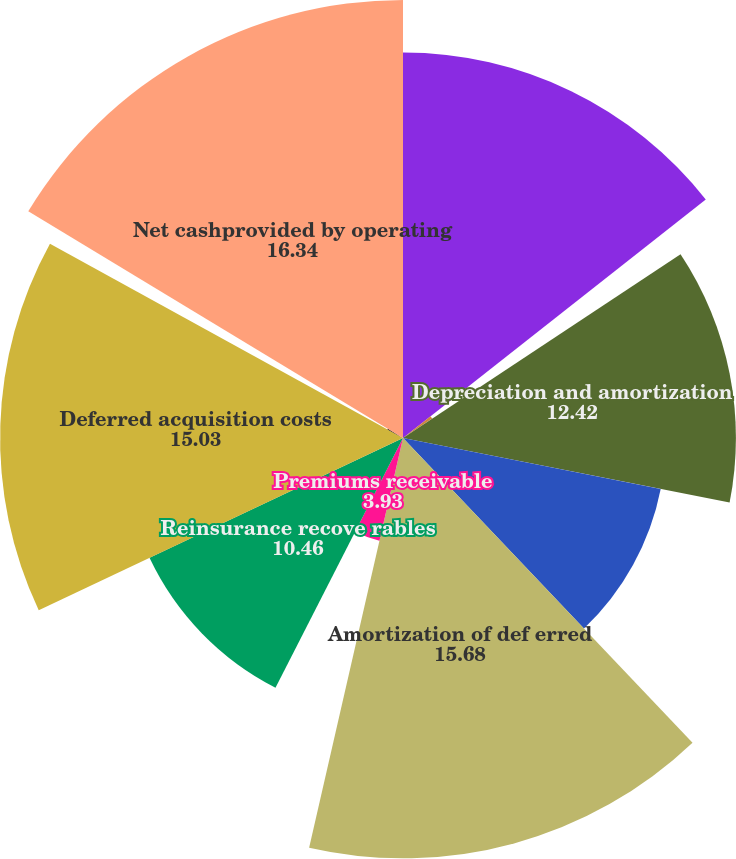Convert chart to OTSL. <chart><loc_0><loc_0><loc_500><loc_500><pie_chart><fcel>For the year ended December 31<fcel>Netrealized investment (gains)<fcel>Depreciation and amortization<fcel>Deferred federal income tax<fcel>Amortization of def erred<fcel>Premiums receivable<fcel>Reinsurance recove rables<fcel>Deferred acquisition costs<fcel>Trading account activities<fcel>Net cashprovided by operating<nl><fcel>14.38%<fcel>1.31%<fcel>12.42%<fcel>9.8%<fcel>15.68%<fcel>3.93%<fcel>10.46%<fcel>15.03%<fcel>0.66%<fcel>16.34%<nl></chart> 